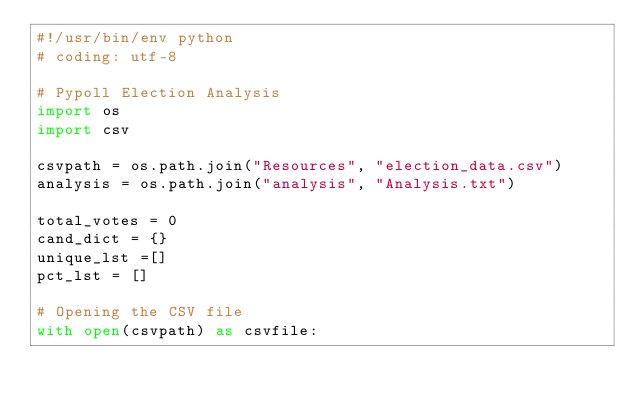Convert code to text. <code><loc_0><loc_0><loc_500><loc_500><_Python_>#!/usr/bin/env python
# coding: utf-8

# Pypoll Election Analysis
import os
import csv

csvpath = os.path.join("Resources", "election_data.csv")
analysis = os.path.join("analysis", "Analysis.txt")

total_votes = 0
cand_dict = {}
unique_lst =[]
pct_lst = []

# Opening the CSV file
with open(csvpath) as csvfile:</code> 